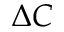<formula> <loc_0><loc_0><loc_500><loc_500>\Delta C</formula> 